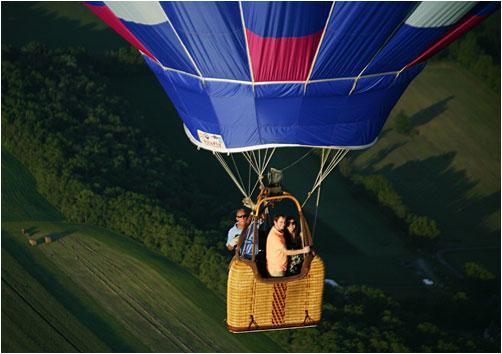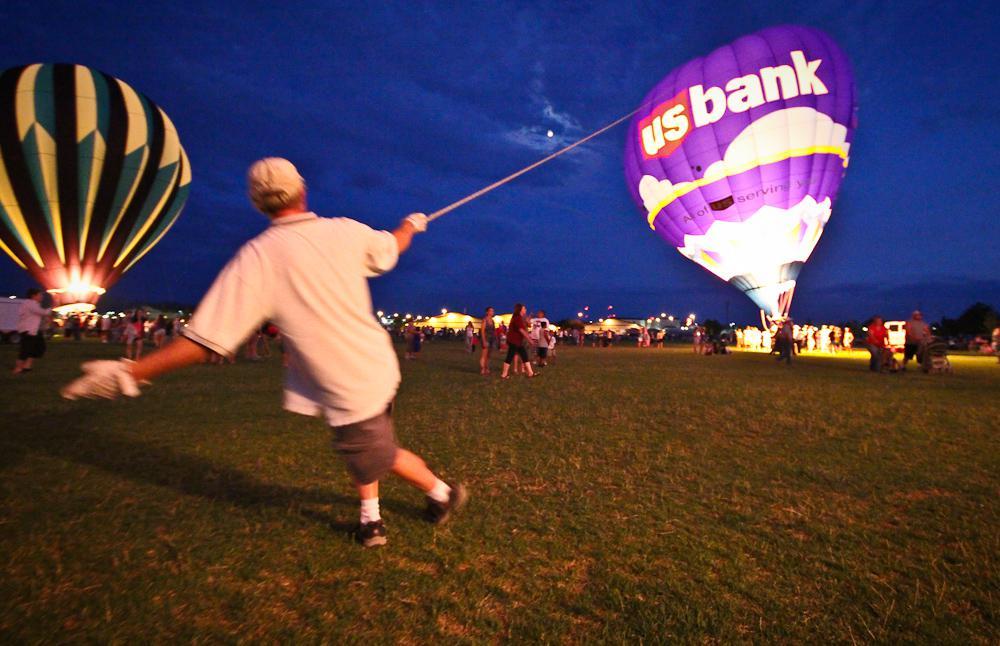The first image is the image on the left, the second image is the image on the right. Given the left and right images, does the statement "Both images show people in hot air balloon baskets floating in midair." hold true? Answer yes or no. No. The first image is the image on the left, the second image is the image on the right. Examine the images to the left and right. Is the description "An image shows a person standing on the ground in a field with hot air balloon." accurate? Answer yes or no. Yes. 